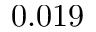<formula> <loc_0><loc_0><loc_500><loc_500>0 . 0 1 9</formula> 